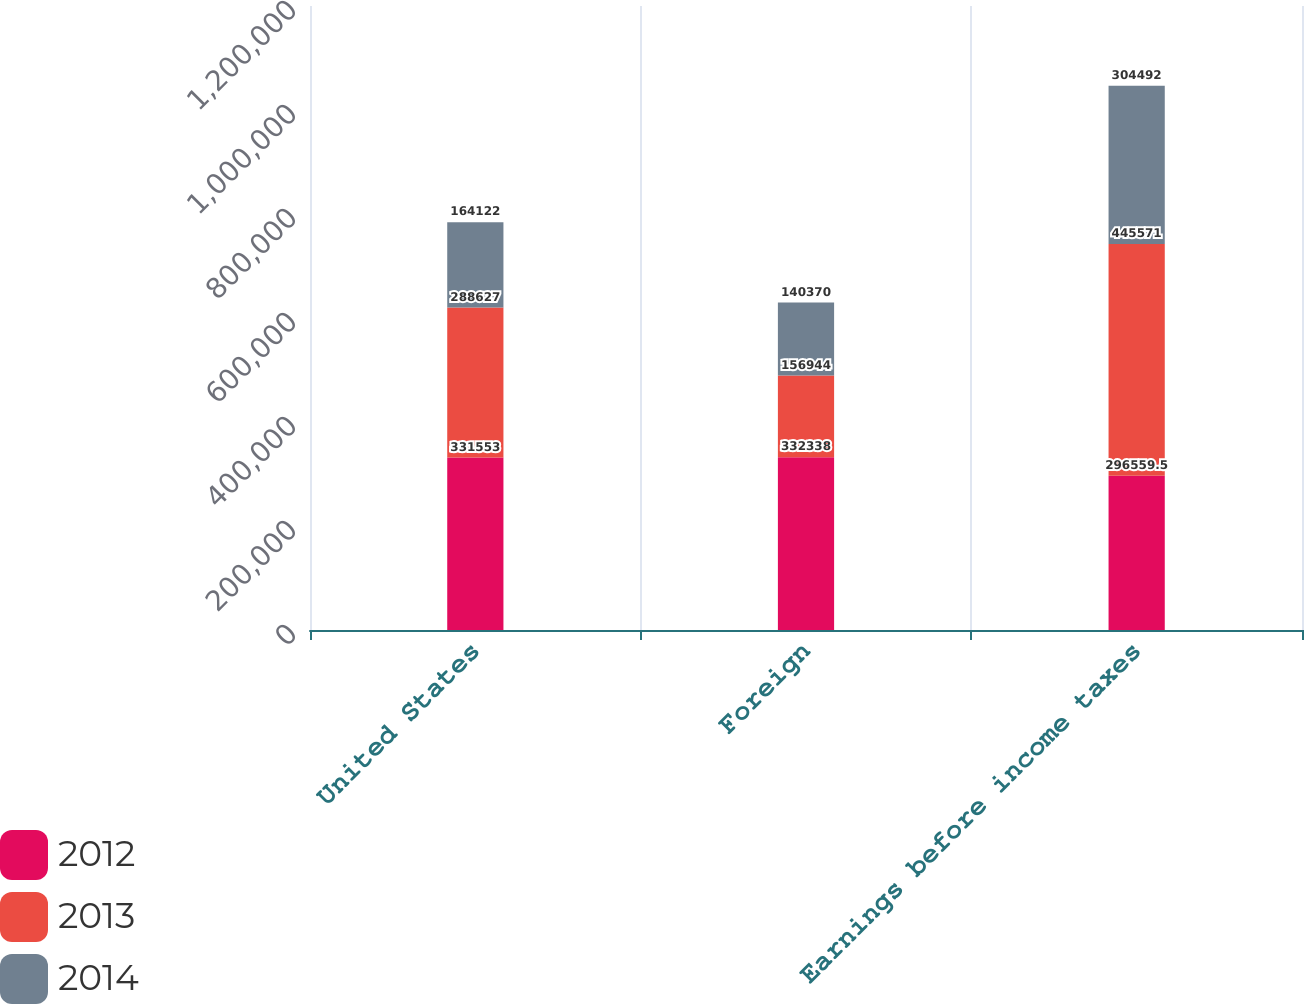Convert chart to OTSL. <chart><loc_0><loc_0><loc_500><loc_500><stacked_bar_chart><ecel><fcel>United States<fcel>Foreign<fcel>Earnings before income taxes<nl><fcel>2012<fcel>331553<fcel>332338<fcel>296560<nl><fcel>2013<fcel>288627<fcel>156944<fcel>445571<nl><fcel>2014<fcel>164122<fcel>140370<fcel>304492<nl></chart> 